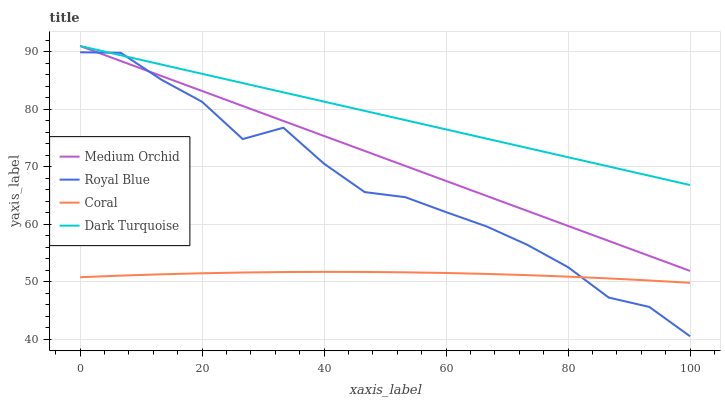Does Medium Orchid have the minimum area under the curve?
Answer yes or no. No. Does Medium Orchid have the maximum area under the curve?
Answer yes or no. No. Is Coral the smoothest?
Answer yes or no. No. Is Coral the roughest?
Answer yes or no. No. Does Coral have the lowest value?
Answer yes or no. No. Does Coral have the highest value?
Answer yes or no. No. Is Coral less than Dark Turquoise?
Answer yes or no. Yes. Is Medium Orchid greater than Coral?
Answer yes or no. Yes. Does Coral intersect Dark Turquoise?
Answer yes or no. No. 